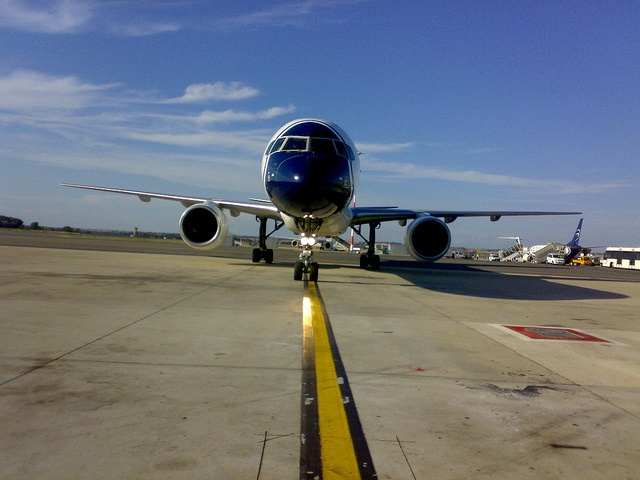Describe the objects in this image and their specific colors. I can see airplane in gray, black, navy, and darkgray tones, airplane in gray, black, navy, and ivory tones, car in gray, darkgray, beige, and black tones, car in gray, black, and darkgreen tones, and car in gray, black, darkgray, and khaki tones in this image. 